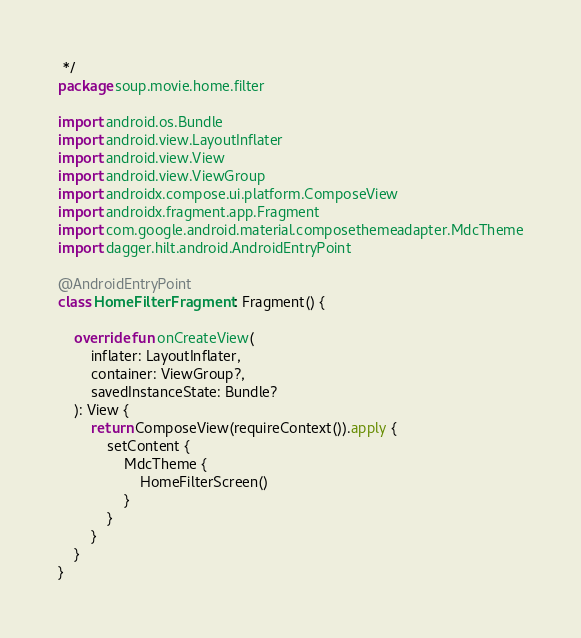<code> <loc_0><loc_0><loc_500><loc_500><_Kotlin_> */
package soup.movie.home.filter

import android.os.Bundle
import android.view.LayoutInflater
import android.view.View
import android.view.ViewGroup
import androidx.compose.ui.platform.ComposeView
import androidx.fragment.app.Fragment
import com.google.android.material.composethemeadapter.MdcTheme
import dagger.hilt.android.AndroidEntryPoint

@AndroidEntryPoint
class HomeFilterFragment : Fragment() {

    override fun onCreateView(
        inflater: LayoutInflater,
        container: ViewGroup?,
        savedInstanceState: Bundle?
    ): View {
        return ComposeView(requireContext()).apply {
            setContent {
                MdcTheme {
                    HomeFilterScreen()
                }
            }
        }
    }
}
</code> 